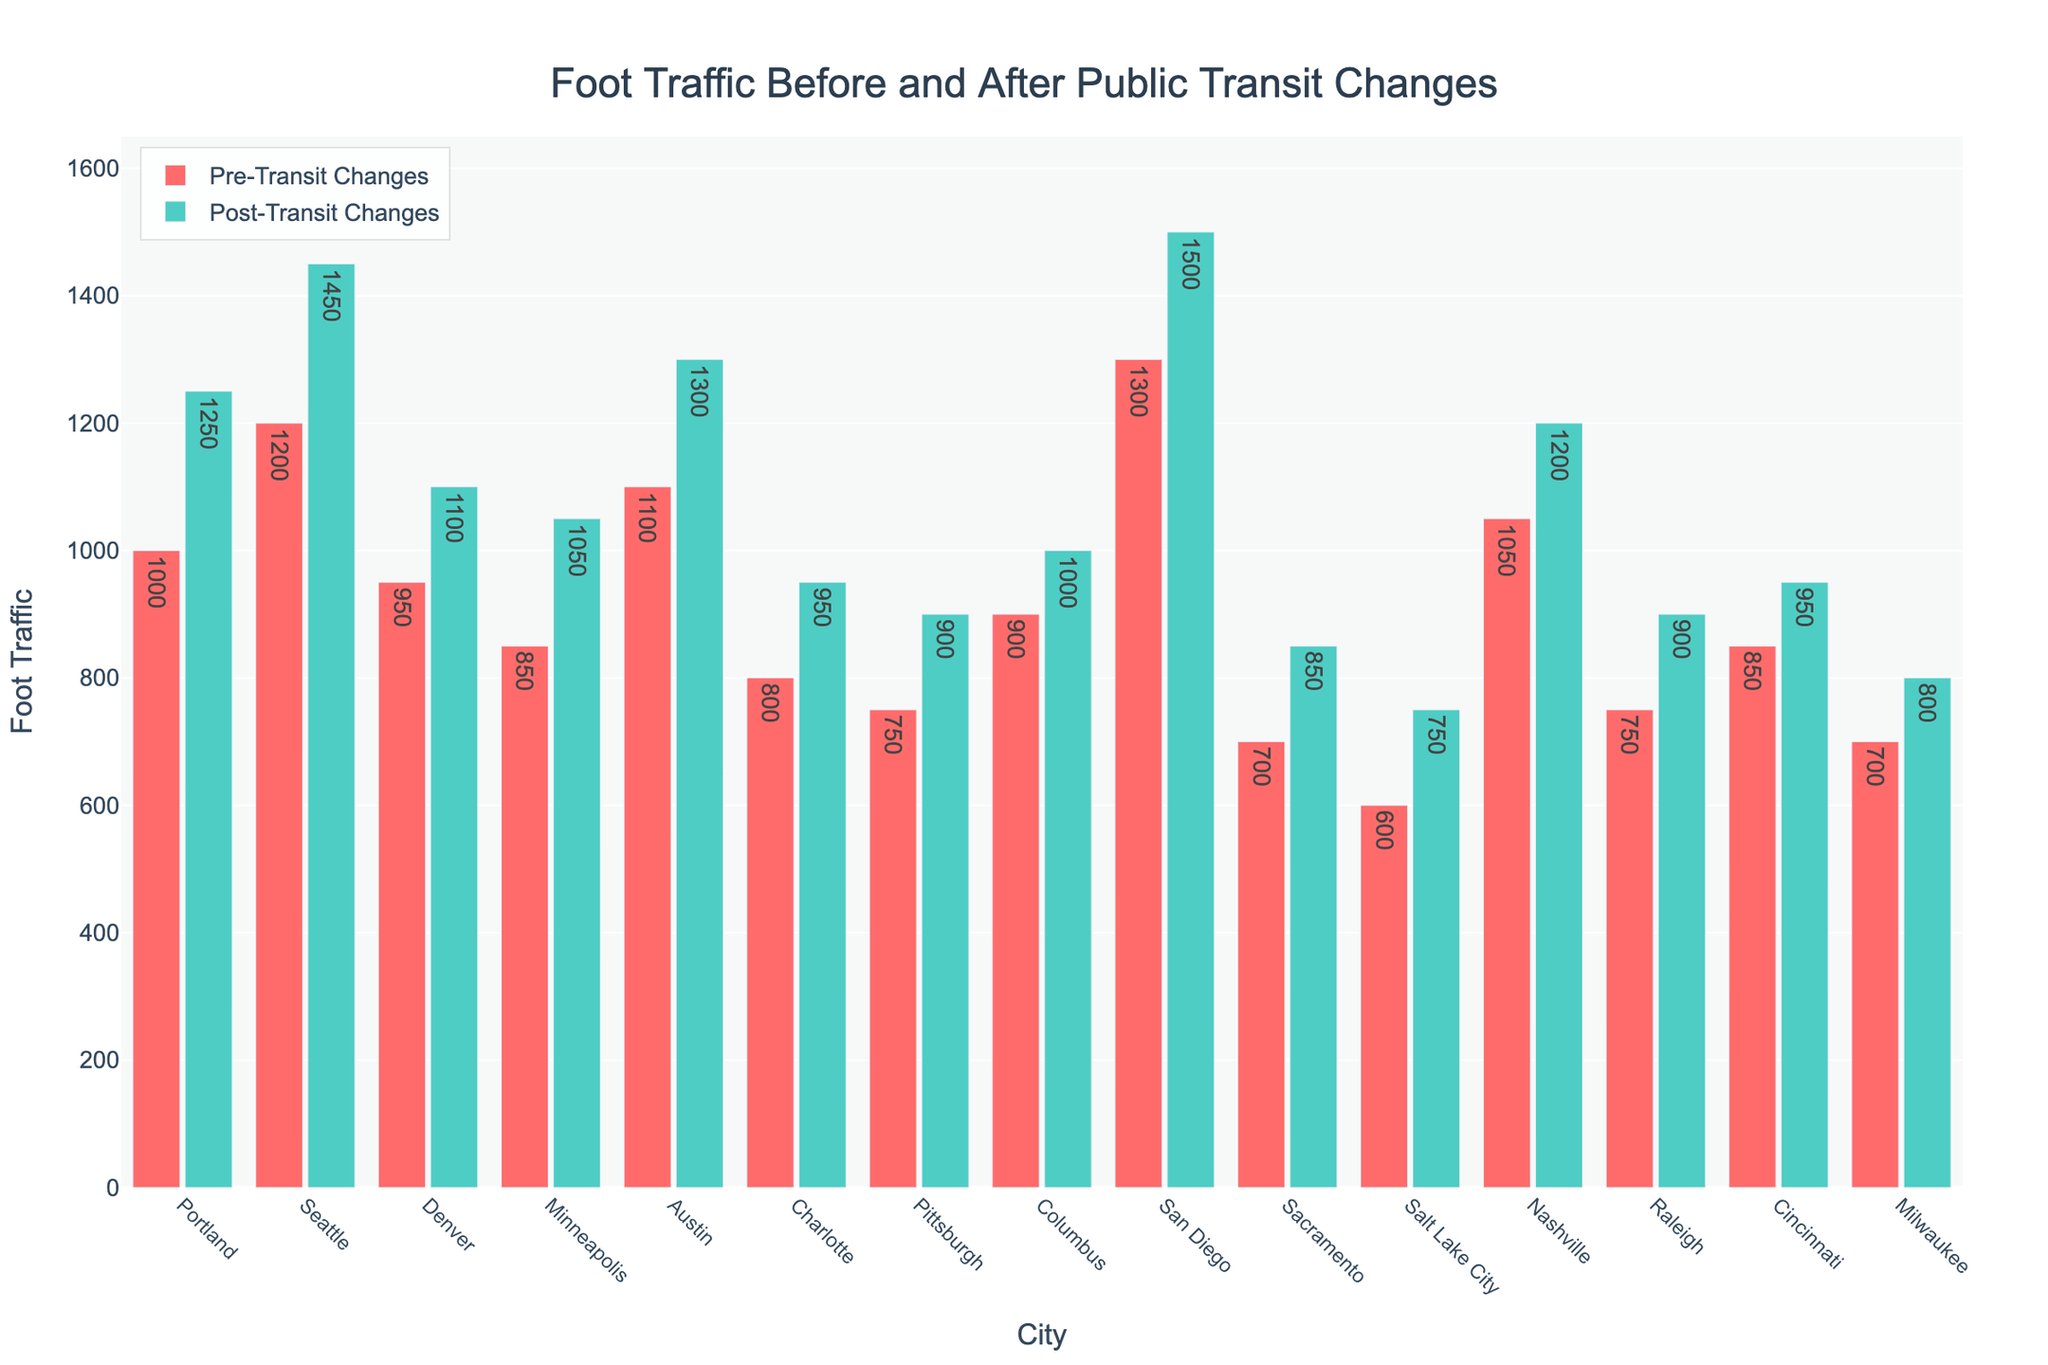what is the difference in foot traffic in Seattle before and after the transit changes? From the chart, Seattle's pre-transit foot traffic is 1200, and post-transit foot traffic is 1450. The difference is 1450 - 1200.
Answer: 250 Which city has the highest post-transit foot traffic? By looking at the chart, San Diego has the highest post-transit foot traffic of 1500.
Answer: San Diego Which city had the lowest increase in foot traffic after the public transit changes? From the chart, Salt Lake City had a pre-transit foot traffic of 600 and a post-transit foot traffic of 750, resulting in an increase of 150, which is the smallest increase among all cities.
Answer: Salt Lake City Are there any cities where the post-transit changes foot traffic is less than the pre-transit changes foot traffic? By observing the chart, all cities have higher foot traffic post-transit changes compared to pre-transit changes.
Answer: No What is the total foot traffic in Austin before and after the transit changes? In Austin, the pre-transit foot traffic is 1100 and the post-transit foot traffic is 1300. The total is 1100 + 1300.
Answer: 2400 What is the average foot traffic increase across all the cities after the transit changes? The increases in foot traffic for all cities are: 250, 250, 150, 200, 200, 150, 150, 100, 200, 150, 150, 150, 150, 100, 100. Adding these up yields 2500. The average is 2500/15.
Answer: 167 Which city had the highest percentage increase in foot traffic after the transit changes? To find the highest percentage increase, we calculate percentage increases for all cities. For example, Portland had a pre-transit foot traffic of 1000 and a post-transit foot traffic of 1250. The percentage increase is ((1250 - 1000) / 1000) * 100 = 25%. Repeat this for all cities. The highest percentage increase belongs to Salt Lake City with a 25% increase ((750 - 600) / 600) * 100.
Answer: Salt Lake City What is the cumulative post-transit foot traffic for the top three cities by foot traffic increase? The top three cities by foot traffic increase are Seattle, Portland, and Austin with increases of 250 each. Their post-transit foot traffic values are 1450, 1250, and 1300 respectively. Summing these, 1450 + 1250 + 1300.
Answer: 4000 What is the ratio of post-transit to pre-transit foot traffic for Sacramento? Sacramento's pre-transit foot traffic is 700 and the post-transit foot traffic is 850. The ratio is 850/700.
Answer: 1.21 